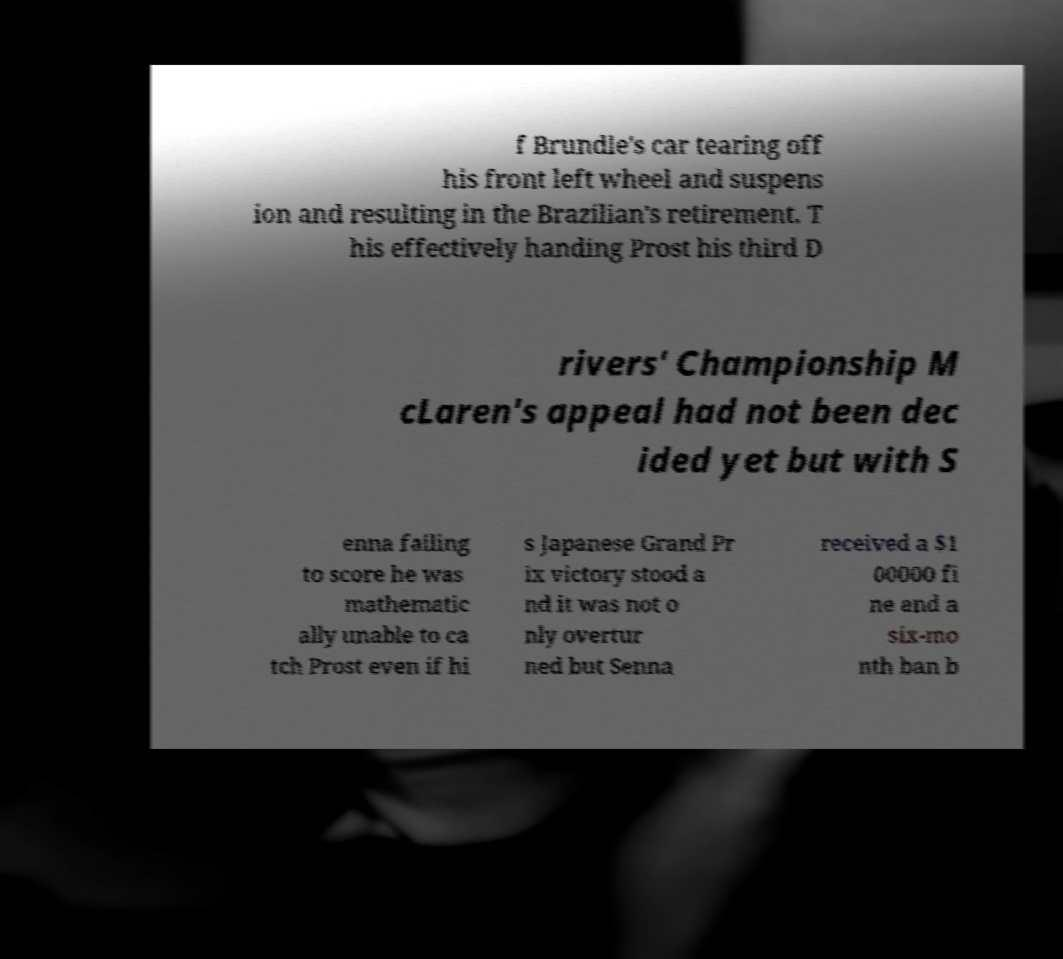Can you read and provide the text displayed in the image?This photo seems to have some interesting text. Can you extract and type it out for me? f Brundle's car tearing off his front left wheel and suspens ion and resulting in the Brazilian's retirement. T his effectively handing Prost his third D rivers' Championship M cLaren's appeal had not been dec ided yet but with S enna failing to score he was mathematic ally unable to ca tch Prost even if hi s Japanese Grand Pr ix victory stood a nd it was not o nly overtur ned but Senna received a $1 00000 fi ne and a six-mo nth ban b 